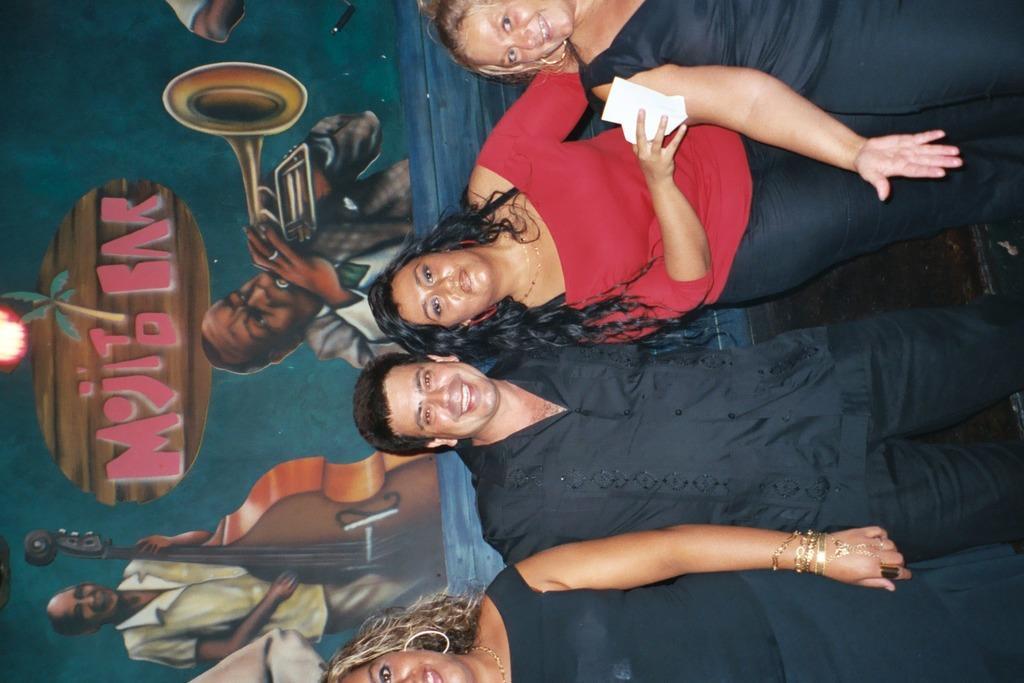Describe this image in one or two sentences. In this image, we can see persons wearing clothes. In the background, we can see a wall contains an art. 